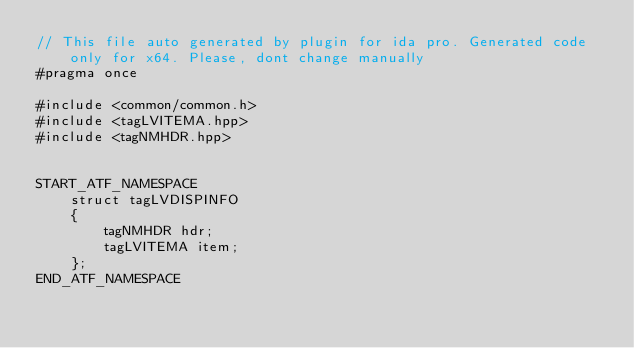Convert code to text. <code><loc_0><loc_0><loc_500><loc_500><_C++_>// This file auto generated by plugin for ida pro. Generated code only for x64. Please, dont change manually
#pragma once

#include <common/common.h>
#include <tagLVITEMA.hpp>
#include <tagNMHDR.hpp>


START_ATF_NAMESPACE
    struct tagLVDISPINFO
    {
        tagNMHDR hdr;
        tagLVITEMA item;
    };
END_ATF_NAMESPACE
</code> 